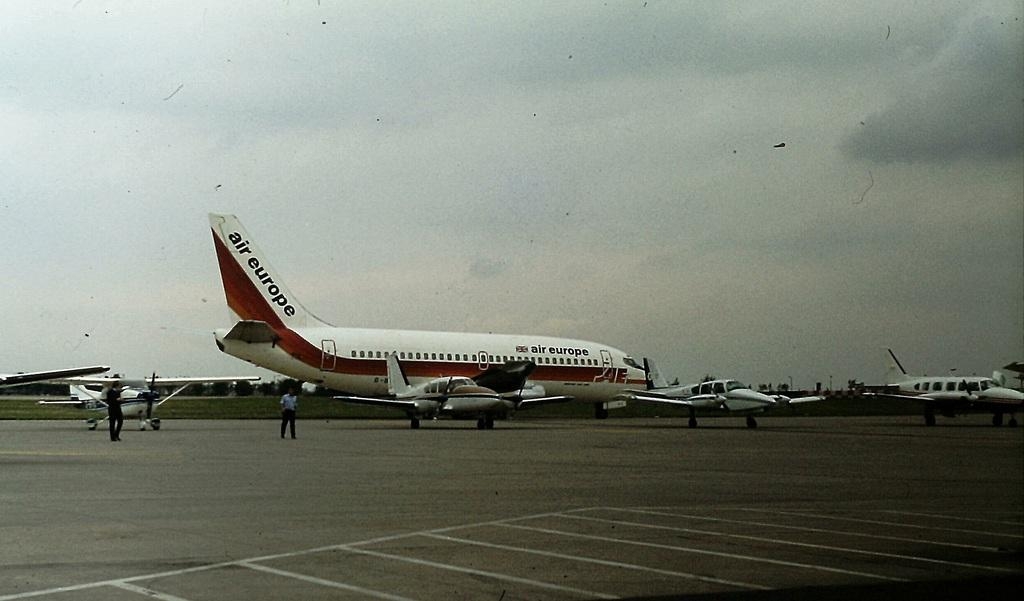<image>
Relay a brief, clear account of the picture shown. An Air Europe plane sits at the airport on a cloudy day. 